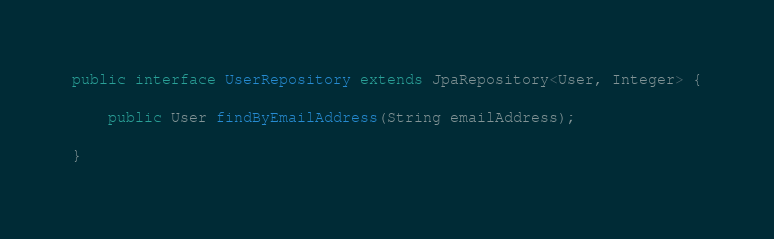<code> <loc_0><loc_0><loc_500><loc_500><_Java_>public interface UserRepository extends JpaRepository<User, Integer> {

	public User findByEmailAddress(String emailAddress);

}
</code> 